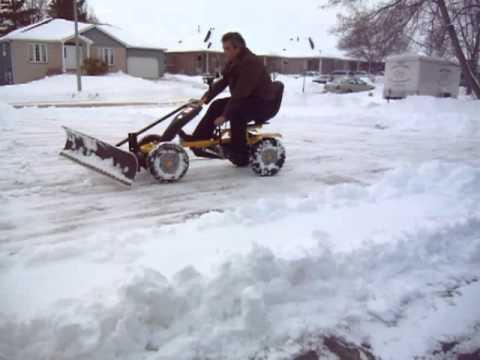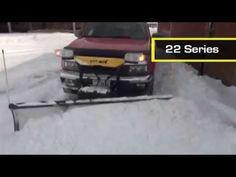The first image is the image on the left, the second image is the image on the right. Given the left and right images, does the statement "In one of the images, a red vehicle is pushing and clearing snow." hold true? Answer yes or no. Yes. The first image is the image on the left, the second image is the image on the right. For the images shown, is this caption "Right image includes a camera-facing plow truck driving toward a curve in a snowy road scene." true? Answer yes or no. No. 